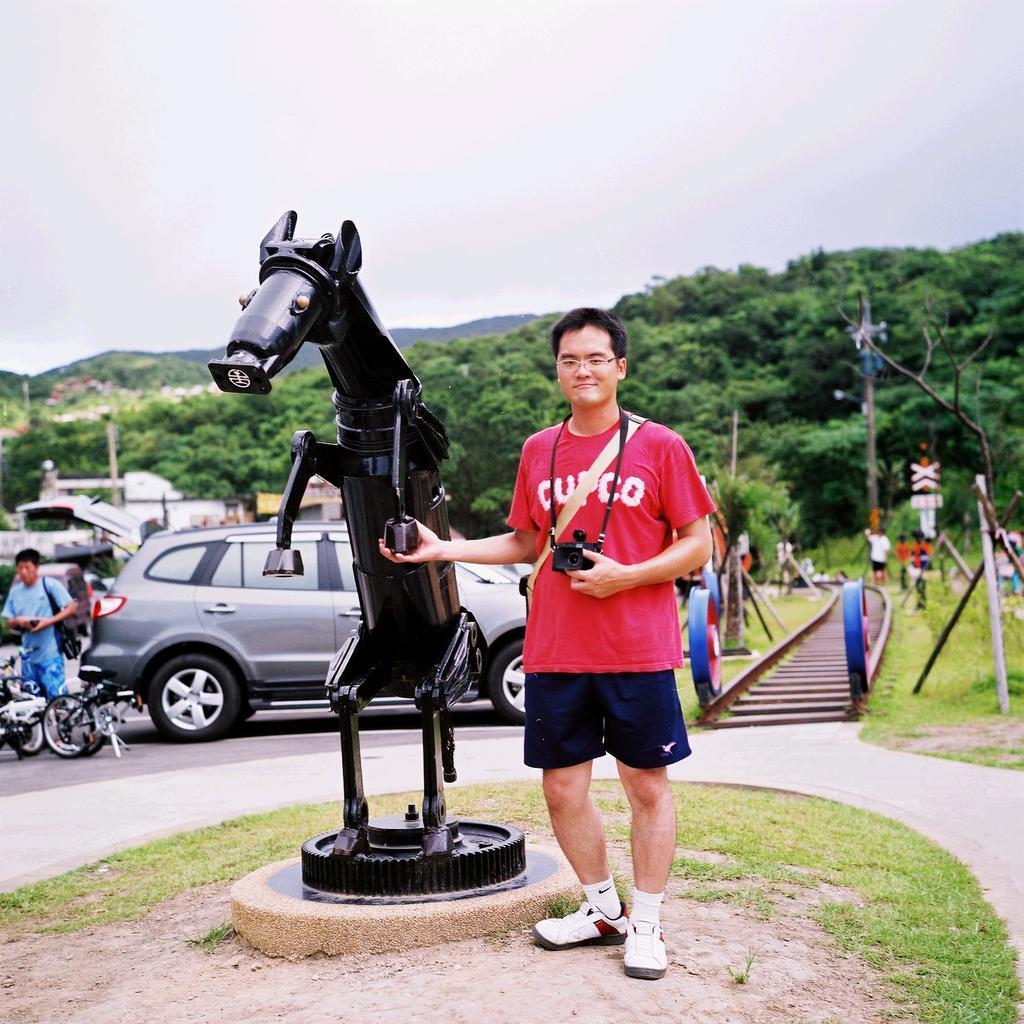Please provide a concise description of this image. In this picture I can see people standing on the surface. I can see statue on the surface. I can see green grass. I can see vehicles on the road. I can see the railway track on the right side. I can see trees. I can see clouds in the sky. 